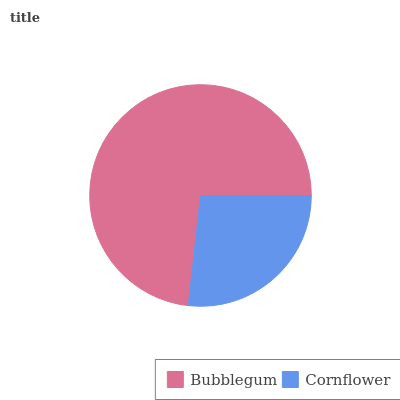Is Cornflower the minimum?
Answer yes or no. Yes. Is Bubblegum the maximum?
Answer yes or no. Yes. Is Cornflower the maximum?
Answer yes or no. No. Is Bubblegum greater than Cornflower?
Answer yes or no. Yes. Is Cornflower less than Bubblegum?
Answer yes or no. Yes. Is Cornflower greater than Bubblegum?
Answer yes or no. No. Is Bubblegum less than Cornflower?
Answer yes or no. No. Is Bubblegum the high median?
Answer yes or no. Yes. Is Cornflower the low median?
Answer yes or no. Yes. Is Cornflower the high median?
Answer yes or no. No. Is Bubblegum the low median?
Answer yes or no. No. 